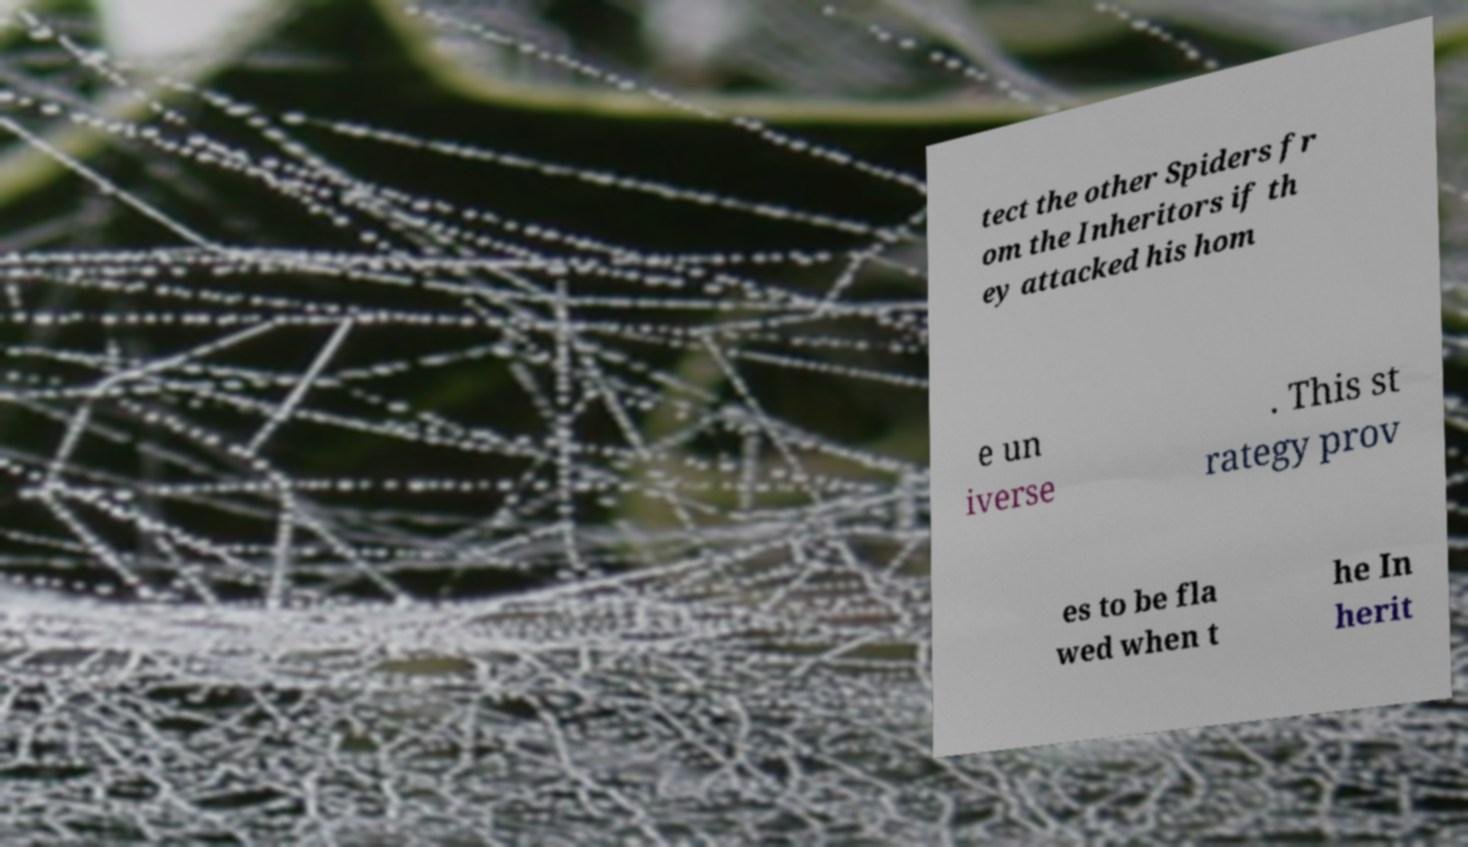Could you extract and type out the text from this image? tect the other Spiders fr om the Inheritors if th ey attacked his hom e un iverse . This st rategy prov es to be fla wed when t he In herit 